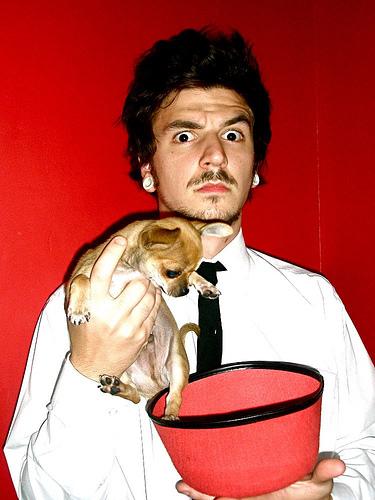What color is the basket the man is holding?
Be succinct. Red. Is the man sad at the dog?
Write a very short answer. No. What kind of dog is this?
Be succinct. Chihuahua. 